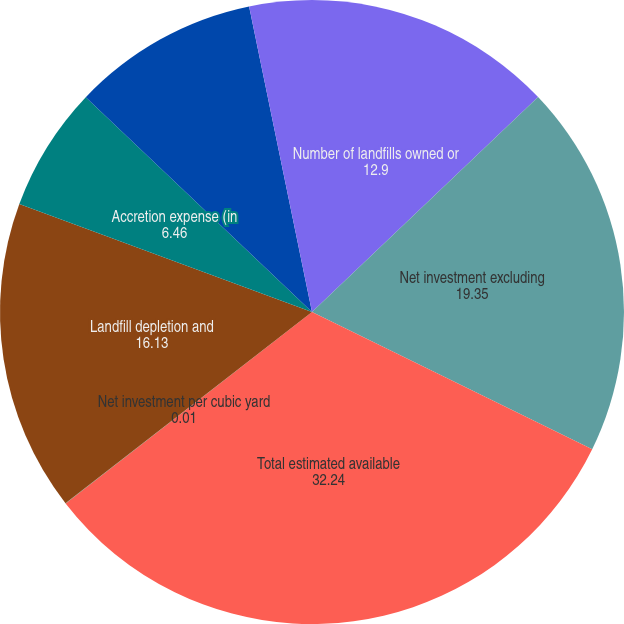<chart> <loc_0><loc_0><loc_500><loc_500><pie_chart><fcel>Number of landfills owned or<fcel>Net investment excluding<fcel>Total estimated available<fcel>Net investment per cubic yard<fcel>Landfill depletion and<fcel>Accretion expense (in<fcel>Airspace consumed (in millions<fcel>Depletion amortization and<nl><fcel>12.9%<fcel>19.35%<fcel>32.24%<fcel>0.01%<fcel>16.13%<fcel>6.46%<fcel>9.68%<fcel>3.23%<nl></chart> 